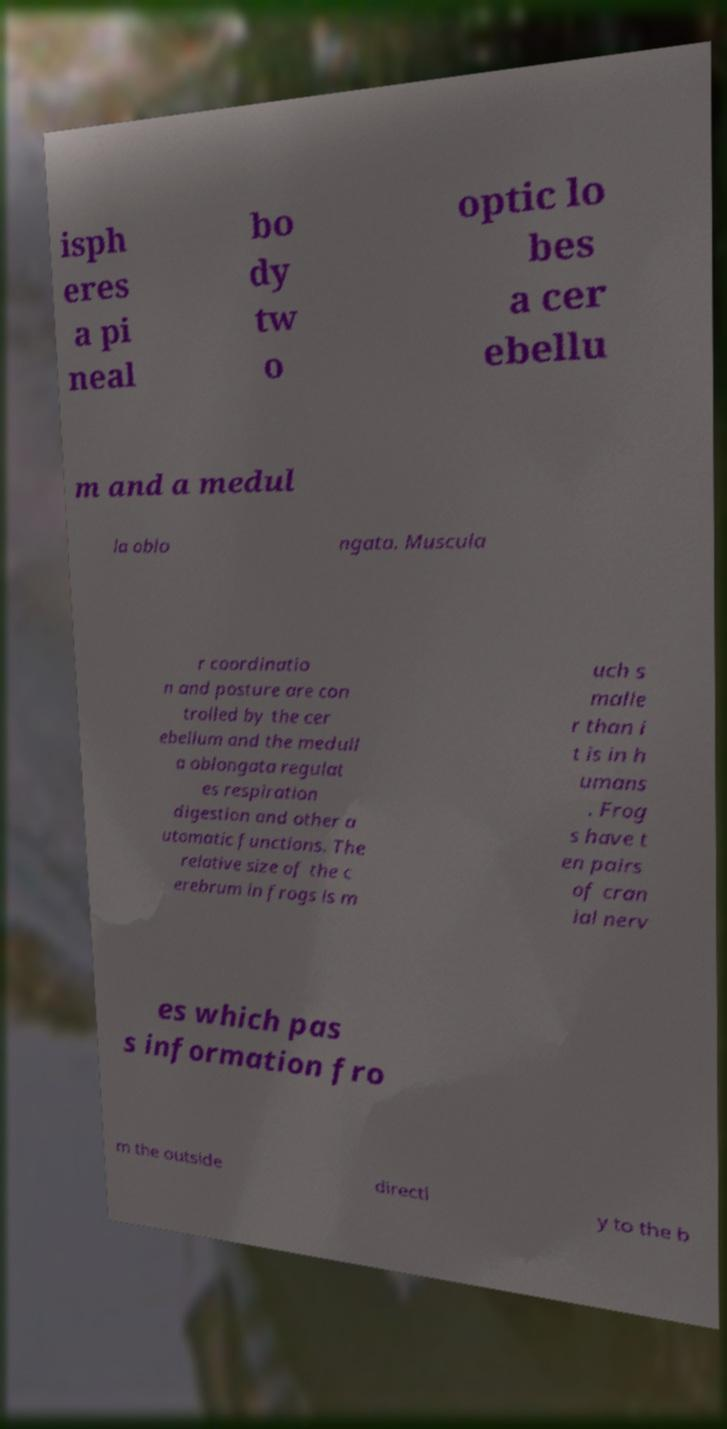Can you accurately transcribe the text from the provided image for me? isph eres a pi neal bo dy tw o optic lo bes a cer ebellu m and a medul la oblo ngata. Muscula r coordinatio n and posture are con trolled by the cer ebellum and the medull a oblongata regulat es respiration digestion and other a utomatic functions. The relative size of the c erebrum in frogs is m uch s malle r than i t is in h umans . Frog s have t en pairs of cran ial nerv es which pas s information fro m the outside directl y to the b 